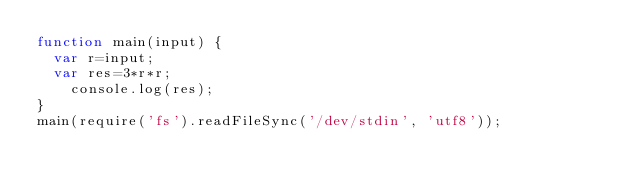Convert code to text. <code><loc_0><loc_0><loc_500><loc_500><_JavaScript_>function main(input) {
  var r=input;
  var res=3*r*r;
    console.log(res);
}
main(require('fs').readFileSync('/dev/stdin', 'utf8'));</code> 